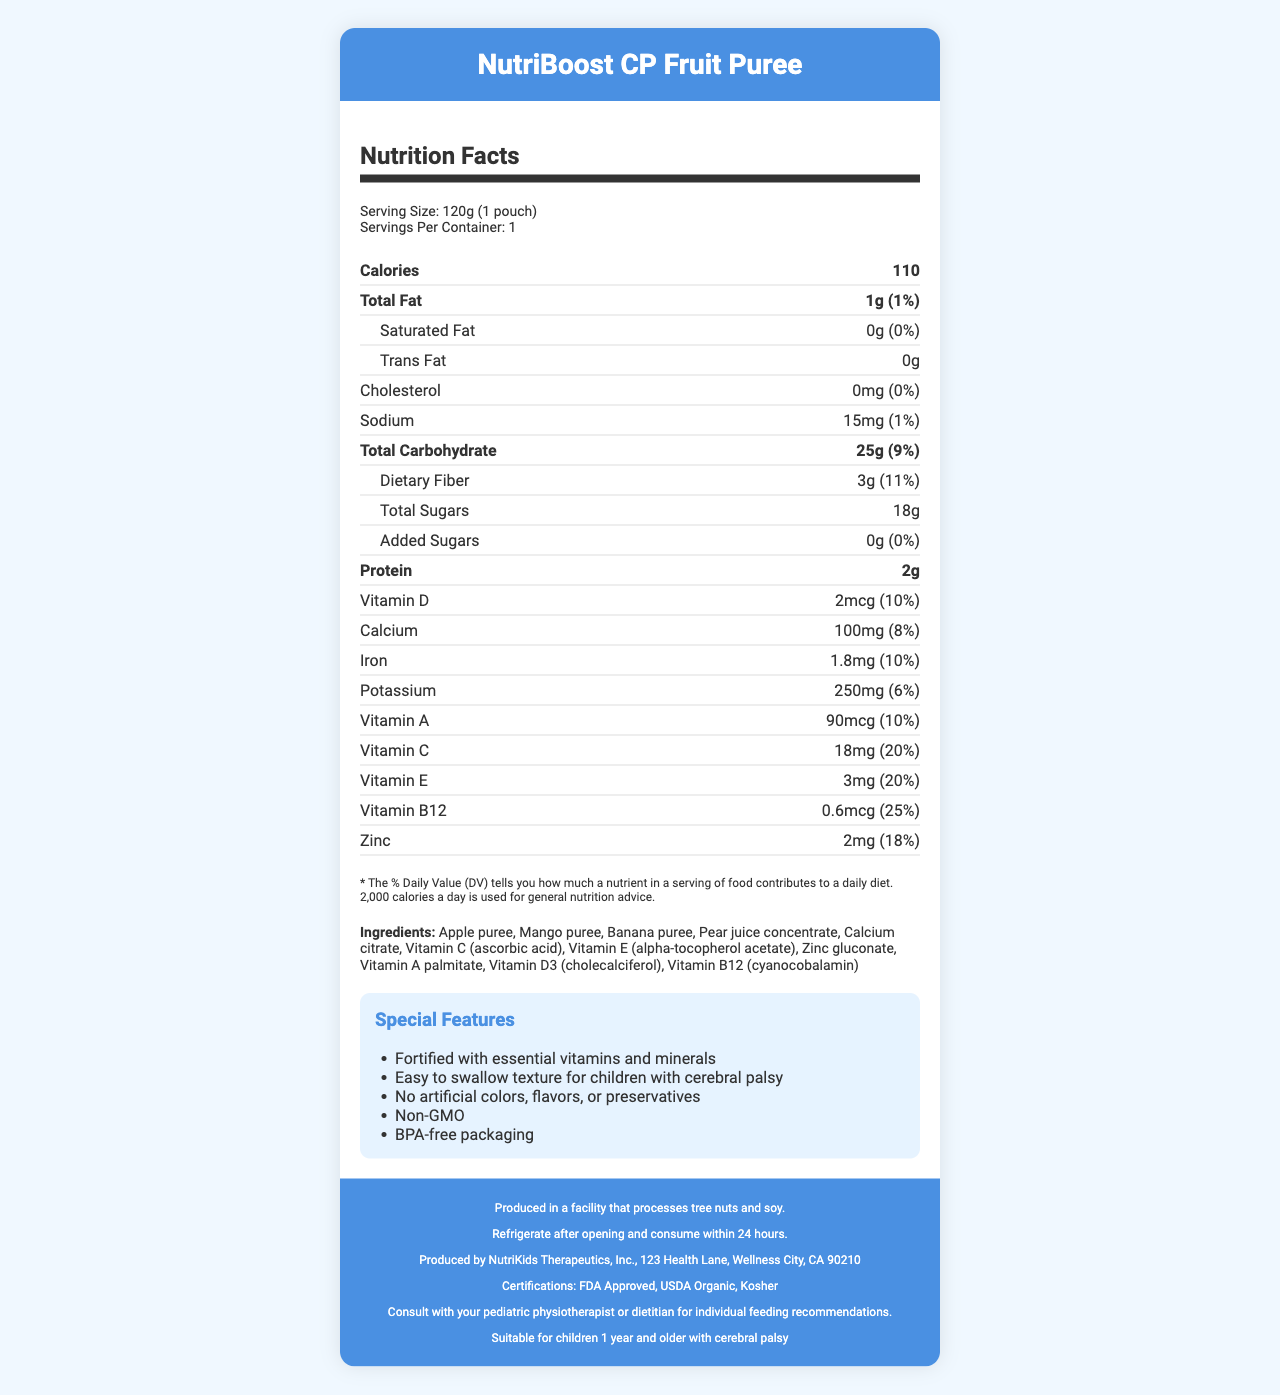what is the serving size for NutriBoost CP Fruit Puree? The document specifies the serving size as "120g (1 pouch)" in the serving information section.
Answer: 120g (1 pouch) how many calories are in one serving of NutriBoost CP Fruit Puree? The calories are indicated as "110" in the nutrient facts section under the bold "Calories" row.
Answer: 110 what is the percent daily value of Vitamin C in NutriBoost CP Fruit Puree? The percent daily value for Vitamin C is listed as "20%" in the vitamins and minerals section of the nutrient facts.
Answer: 20% how much protein does one pouch of NutriBoost CP Fruit Puree contain? The protein amount is stated as "2g" in the bold "Protein" section of the nutrient facts.
Answer: 2g does NutriBoost CP Fruit Puree contain any added sugars? The document states that the amount of added sugars is "0g" and the daily value is "0%", which means there are no added sugars.
Answer: No which ingredient is used as a source of Vitamin C in NutriBoost CP Fruit Puree? A. Calcium Citrate B. Zinc Gluconate C. Vitamin C (ascorbic acid) D. Vitamin A Palmitate The ingredients list specifies "Vitamin C (ascorbic acid)" as the source of Vitamin C.
Answer: C how many milligrams of calcium are in a single serving of NutriBoost CP Fruit Puree? The nutrient facts indicate that the amount of calcium is "100mg".
Answer: 100mg is there any cholesterol in NutriBoost CP Fruit Puree? The document shows "Cholesterol: 0mg (0%)" in the nutrient facts section.
Answer: No summarize the main features of NutriBoost CP Fruit Puree. The summary combines details from the special features, serving information, allergen warning, storage instructions, and overall nutrient content.
Answer: NutriBoost CP Fruit Puree is a fortified fruit puree pouch designed for children with cerebral palsy. It contains essential vitamins and minerals, has an easy-to-swallow texture, and is free from artificial colors, flavors, and preservatives. It is non-GMO, comes in BPA-free packaging, and should be refrigerated and consumed within 24 hours after opening. how many grams of dietary fiber does one serving of NutriBoost CP Fruit Puree provide and what is its percent daily value? The document lists dietary fiber as "3g (11%)" in the total carbohydrate section.
Answer: 3g, 11% which of the following certifications does NutriBoost CP Fruit Puree hold? A. FDA Approved B. USDA Organic C. Kosher D. All of the above The document states that NutriBoost CP Fruit Puree is "FDA Approved," "USDA Organic," and "Kosher," which means it holds all of these certifications.
Answer: D can NutriBoost CP Fruit Puree be considered a source of vitamin D? The nutrient facts indicate that NutriBoost CP Fruit Puree contains 2mcg of Vitamin D, which is 10% of the daily value, making it a source of vitamin D.
Answer: Yes is the amount of total sugars higher or lower than the amount of dietary fiber per serving? The document lists total sugars as "18g" and dietary fiber as "3g" per serving, making total sugars higher.
Answer: Higher what is the address of the manufacturer of NutriBoost CP Fruit Puree? The manufacturer information section provides this address.
Answer: 123 Health Lane, Wellness City, CA 90210 is it safe for children to consume this product if they are allergic to tree nuts? The document states, "Produced in a facility that processes tree nuts and soy," but does not provide specific safety information regarding cross-contamination.
Answer: Cannot be determined 